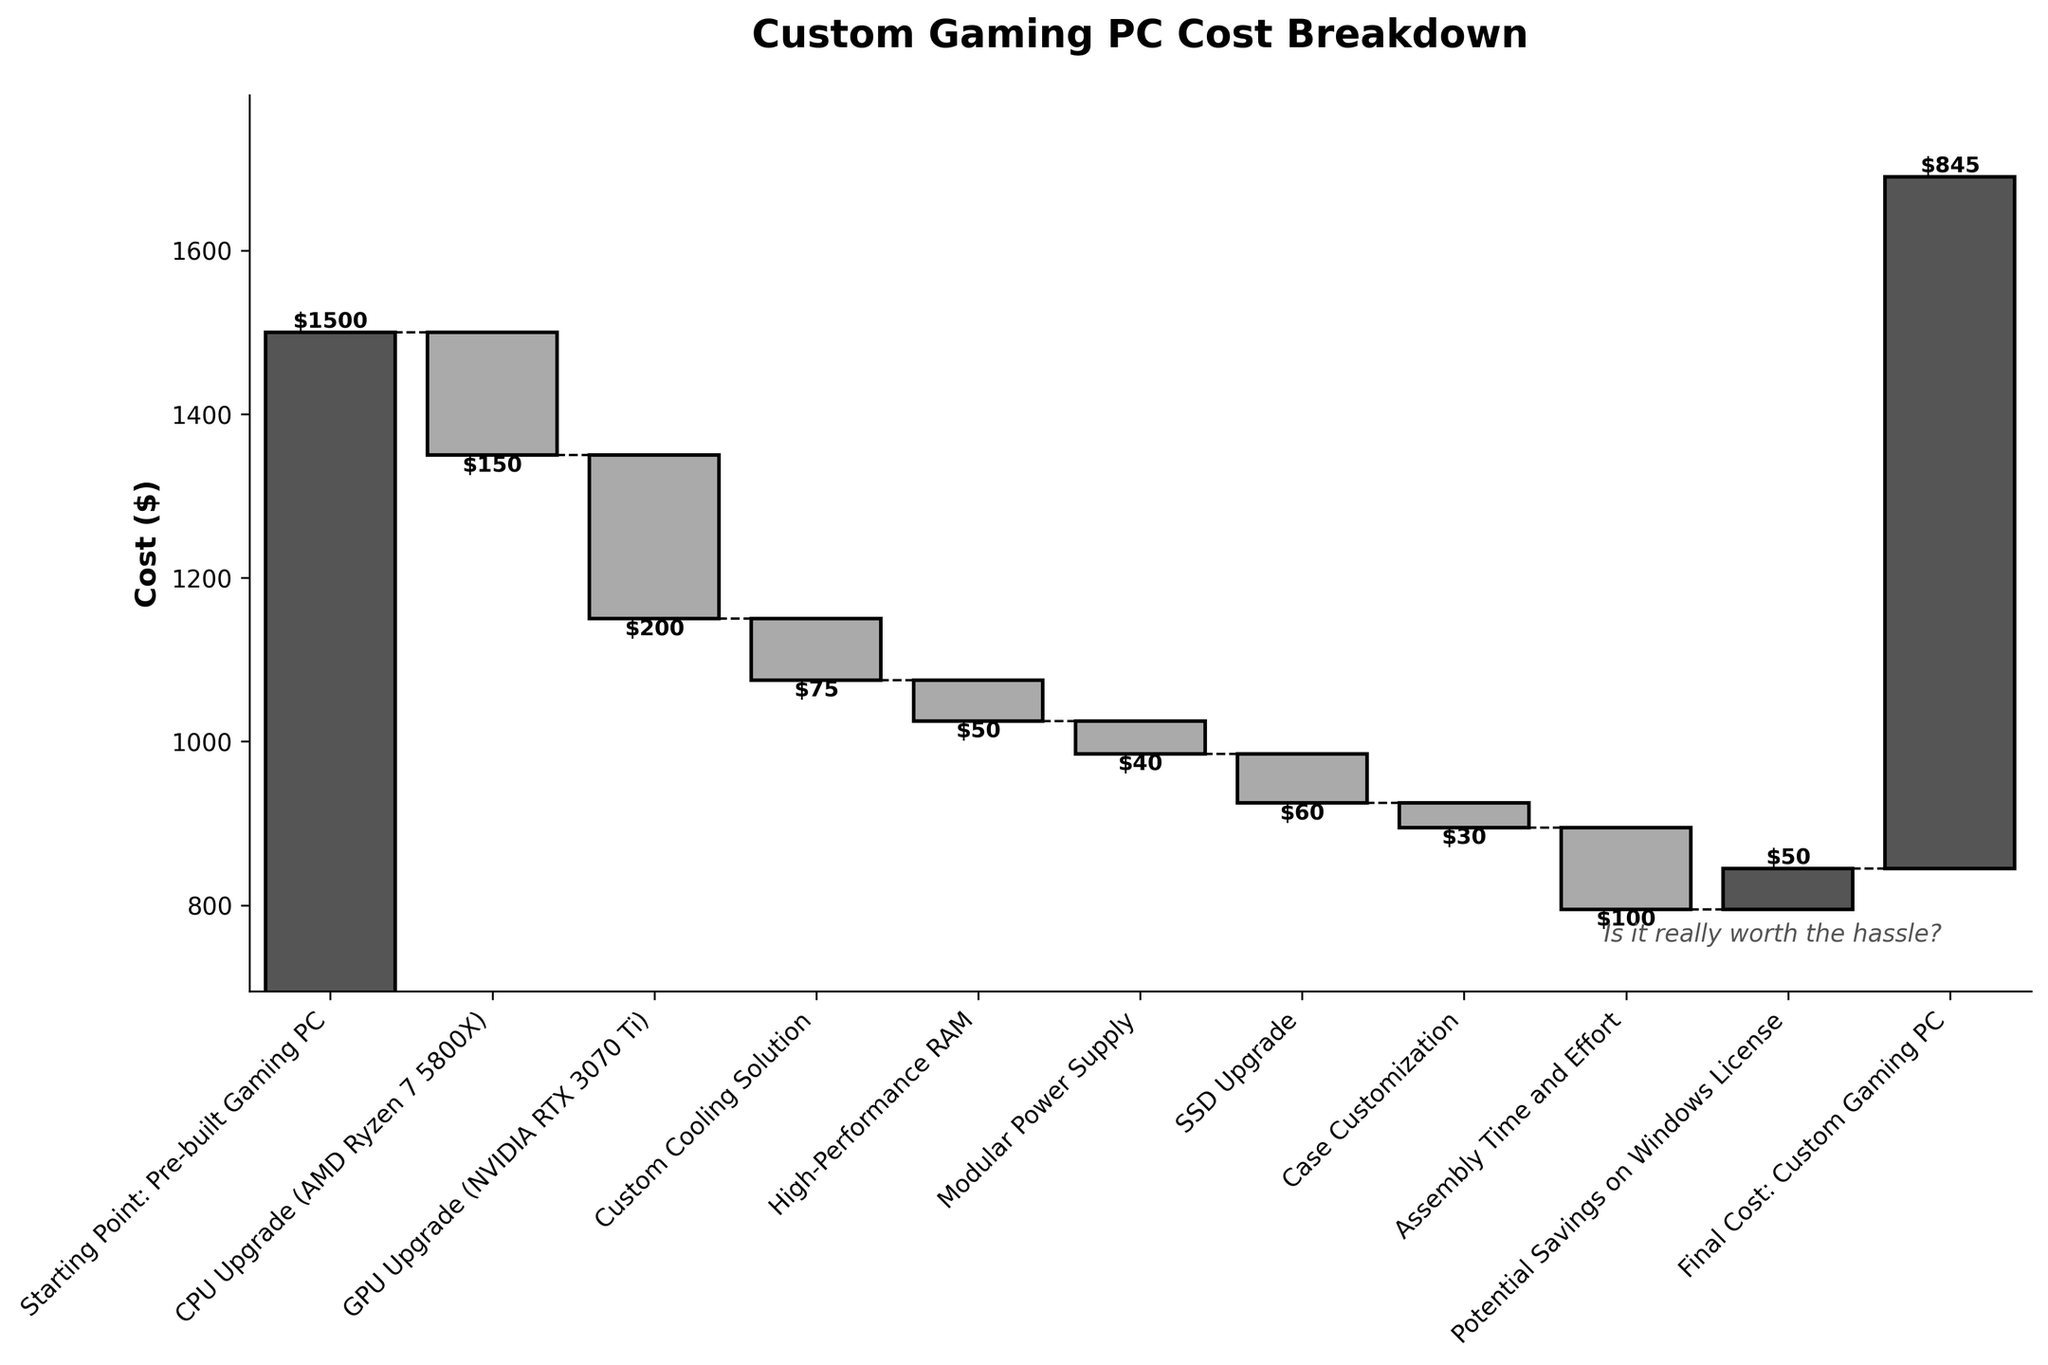What's the title of the chart? The title of the chart is located at the top and summarizes the primary focus of the chart. By looking at the top of the chart, we see that the title is "Custom Gaming PC Cost Breakdown".
Answer: Custom Gaming PC Cost Breakdown What are the axis labels for this chart? The axis labels provide context to what each axis represents. The y-axis label is "Cost ($)" indicating the monetary cost, while the x-axis labels are the different components and efforts associated with building a custom gaming PC versus buying a pre-built one.
Answer: Cost ($), Components/Steps How many individual cost contributions are there in this chart? By counting the number of bars in the chart, including the starting point and final cost, we can tally up the total number of individual contributions. There are 10 entries, as indicated by the 10 bars on the chart.
Answer: 10 Which component contributes the highest savings (reduction in cost)? Savings are indicated by negative bars. To find the highest savings, we identify the component with the tallest bar downward. Notably, the "GPU Upgrade (NVIDIA RTX 3070 Ti)" has a saving of -$200, which is the largest reduction.
Answer: GPU Upgrade (NVIDIA RTX 3070 Ti) What is the total cost difference between the pre-built gaming PC and the custom gaming PC? The starting point for the pre-built gaming PC is $1500, and the final cost for the custom gaming PC is $845. The total cost difference is calculated as $1500 - $845 = $655.
Answer: $655 Which component or step results in an increased cost, rather than savings? By observing the bars that go upward from the starting point, we can see that the "Assembly Time and Effort" and "Potential Savings on Windows License" bars increase. Specifically, "Potential Savings on Windows License" has an incremental positive cost of $50.
Answer: Potential Savings on Windows License What's the cumulative cost of upgrading the CPU, GPU, and adding high-performance RAM? To determine the cumulative cost, we add the absolute values of these cost components: (-$150) + (-$200) + (-$50) = -$400. So the net savings from these three upgrades is $400.
Answer: $400 What is the impact of assembly time and effort on the total cost? The "Assembly Time and Effort" is represented by a bar that brings a positive cost, indicating additional expense. This is shown as increasing the cost by $100.
Answer: Increases by $100 Excluding the starting and final points, which cost component had the smallest impact on the total cost changes (either increase or decrease)? To determine the smallest impact, observe the bars' relative heights. The "Case Customization" and "Modular Power Supply" have impacts of -$30 and -$40 respectively. Among these, the "Case Customization" has the smallest impact at -$30.
Answer: Case Customization 